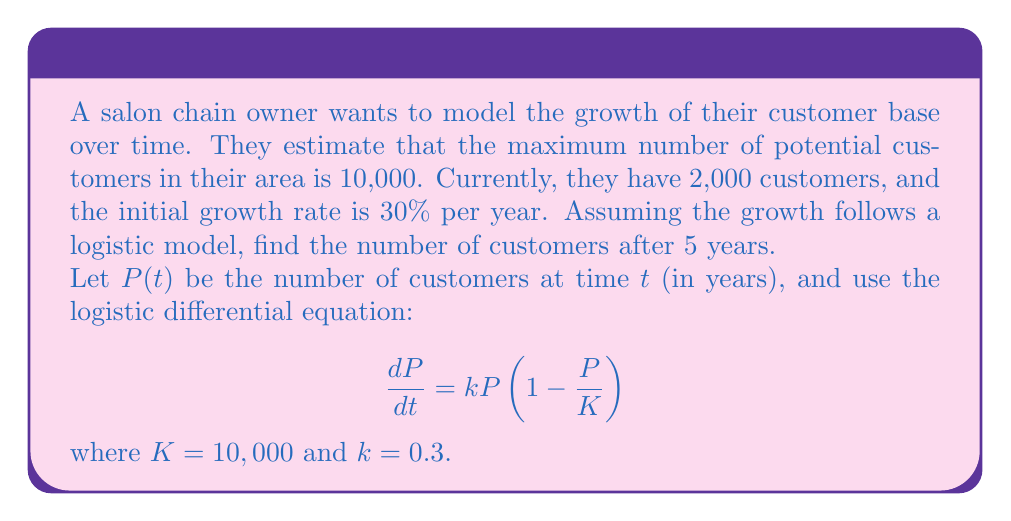What is the answer to this math problem? To solve this problem, we'll use the logistic differential equation and its solution:

1. The logistic differential equation is:
   $$\frac{dP}{dt} = kP(1-\frac{P}{K})$$

2. The solution to this equation is:
   $$P(t) = \frac{K}{1 + Ce^{-kt}}$$

   where $C$ is a constant determined by the initial conditions.

3. We're given:
   - $K = 10,000$ (maximum potential customers)
   - $k = 0.3$ (initial growth rate)
   - $P(0) = 2,000$ (initial number of customers)
   - We need to find $P(5)$

4. To find $C$, we use the initial condition $P(0) = 2,000$:
   $$2,000 = \frac{10,000}{1 + C}$$
   
   Solving for $C$:
   $$C = \frac{10,000}{2,000} - 1 = 4$$

5. Now we can write our specific solution:
   $$P(t) = \frac{10,000}{1 + 4e^{-0.3t}}$$

6. To find $P(5)$, we substitute $t = 5$:
   $$P(5) = \frac{10,000}{1 + 4e^{-0.3(5)}}$$

7. Simplifying:
   $$P(5) = \frac{10,000}{1 + 4e^{-1.5}} \approx 6,449.48$$

8. Rounding to the nearest whole number (as we can't have fractional customers):
   $$P(5) \approx 6,449$$
Answer: After 5 years, the salon chain will have approximately 6,449 customers. 